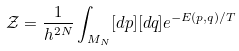Convert formula to latex. <formula><loc_0><loc_0><loc_500><loc_500>{ \mathcal { Z } } = \frac { 1 } { h ^ { 2 N } } \int _ { M _ { N } } [ d { p } ] [ d { q } ] e ^ { - E ( { p } , { q } ) / T }</formula> 